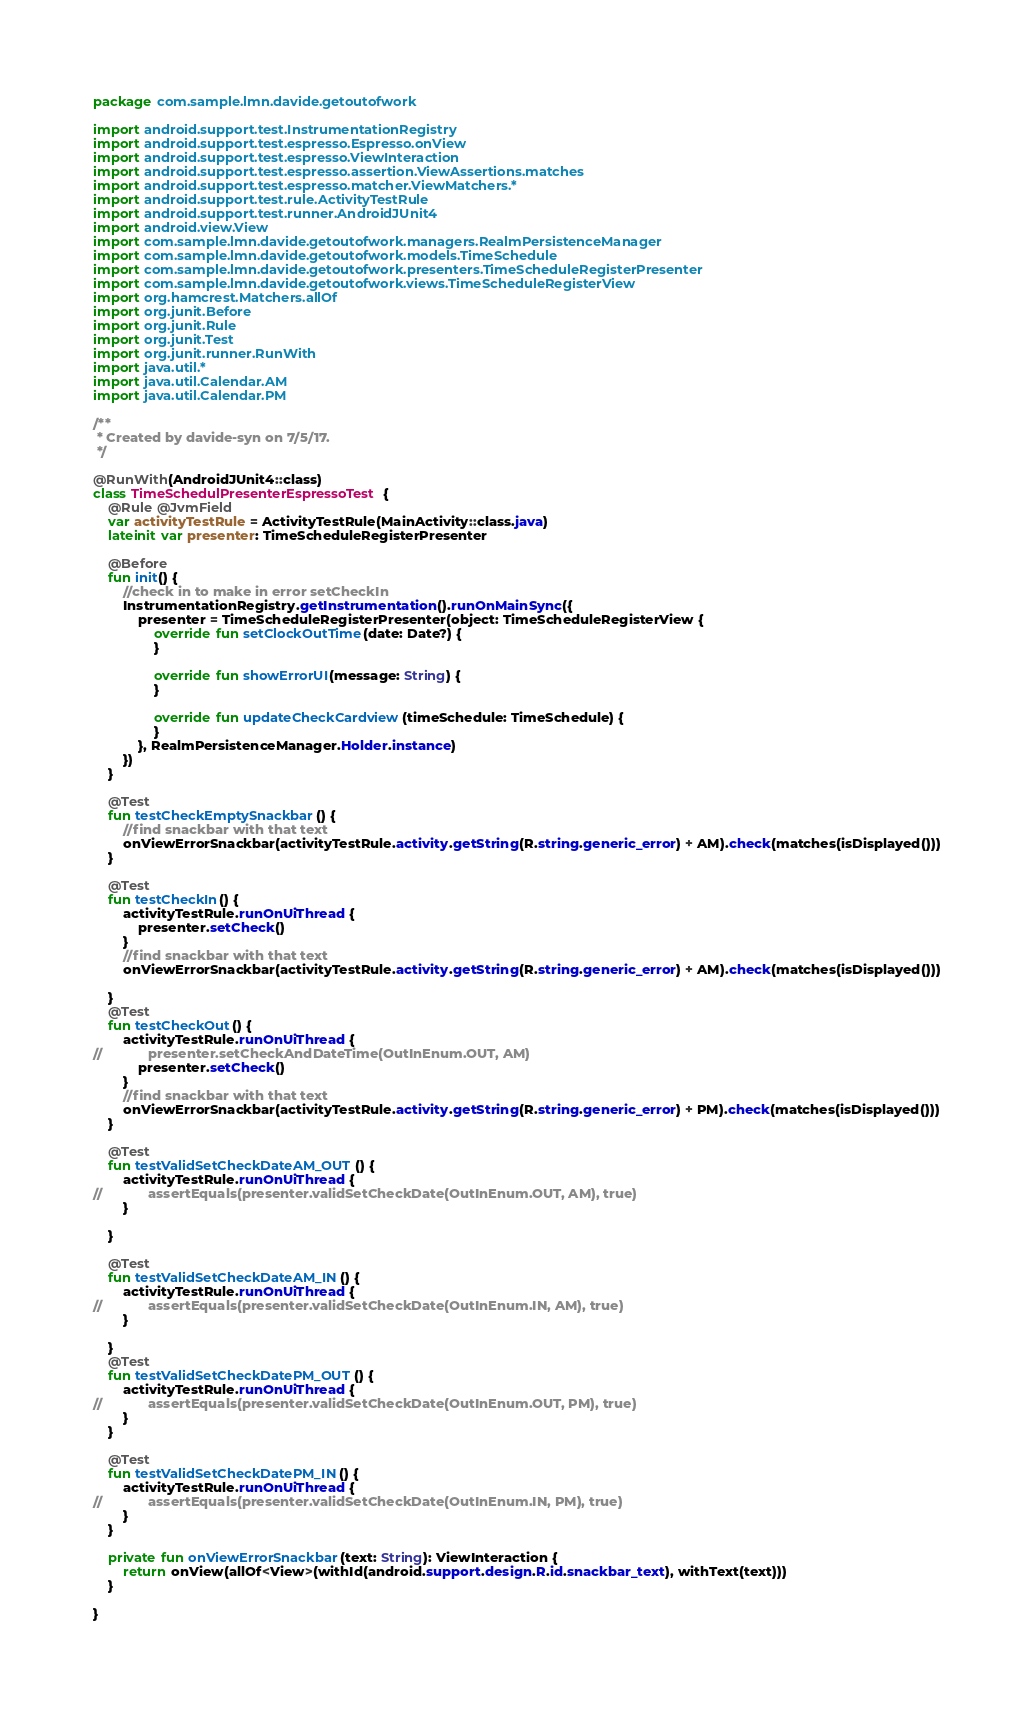Convert code to text. <code><loc_0><loc_0><loc_500><loc_500><_Kotlin_>package com.sample.lmn.davide.getoutofwork

import android.support.test.InstrumentationRegistry
import android.support.test.espresso.Espresso.onView
import android.support.test.espresso.ViewInteraction
import android.support.test.espresso.assertion.ViewAssertions.matches
import android.support.test.espresso.matcher.ViewMatchers.*
import android.support.test.rule.ActivityTestRule
import android.support.test.runner.AndroidJUnit4
import android.view.View
import com.sample.lmn.davide.getoutofwork.managers.RealmPersistenceManager
import com.sample.lmn.davide.getoutofwork.models.TimeSchedule
import com.sample.lmn.davide.getoutofwork.presenters.TimeScheduleRegisterPresenter
import com.sample.lmn.davide.getoutofwork.views.TimeScheduleRegisterView
import org.hamcrest.Matchers.allOf
import org.junit.Before
import org.junit.Rule
import org.junit.Test
import org.junit.runner.RunWith
import java.util.*
import java.util.Calendar.AM
import java.util.Calendar.PM

/**
 * Created by davide-syn on 7/5/17.
 */

@RunWith(AndroidJUnit4::class)
class TimeSchedulPresenterEspressoTest {
    @Rule @JvmField
    var activityTestRule = ActivityTestRule(MainActivity::class.java)
    lateinit var presenter: TimeScheduleRegisterPresenter

    @Before
    fun init() {
        //check in to make in error setCheckIn
        InstrumentationRegistry.getInstrumentation().runOnMainSync({
            presenter = TimeScheduleRegisterPresenter(object: TimeScheduleRegisterView {
                override fun setClockOutTime(date: Date?) {
                }

                override fun showErrorUI(message: String) {
                }

                override fun updateCheckCardview(timeSchedule: TimeSchedule) {
                }
            }, RealmPersistenceManager.Holder.instance)
        })
    }

    @Test
    fun testCheckEmptySnackbar() {
        //find snackbar with that text
        onViewErrorSnackbar(activityTestRule.activity.getString(R.string.generic_error) + AM).check(matches(isDisplayed()))
    }

    @Test
    fun testCheckIn() {
        activityTestRule.runOnUiThread {
            presenter.setCheck()
        }
        //find snackbar with that text
        onViewErrorSnackbar(activityTestRule.activity.getString(R.string.generic_error) + AM).check(matches(isDisplayed()))

    }
    @Test
    fun testCheckOut() {
        activityTestRule.runOnUiThread {
//            presenter.setCheckAndDateTime(OutInEnum.OUT, AM)
            presenter.setCheck()
        }
        //find snackbar with that text
        onViewErrorSnackbar(activityTestRule.activity.getString(R.string.generic_error) + PM).check(matches(isDisplayed()))
    }

    @Test
    fun testValidSetCheckDateAM_OUT() {
        activityTestRule.runOnUiThread {
//            assertEquals(presenter.validSetCheckDate(OutInEnum.OUT, AM), true)
        }

    }

    @Test
    fun testValidSetCheckDateAM_IN() {
        activityTestRule.runOnUiThread {
//            assertEquals(presenter.validSetCheckDate(OutInEnum.IN, AM), true)
        }

    }
    @Test
    fun testValidSetCheckDatePM_OUT() {
        activityTestRule.runOnUiThread {
//            assertEquals(presenter.validSetCheckDate(OutInEnum.OUT, PM), true)
        }
    }

    @Test
    fun testValidSetCheckDatePM_IN() {
        activityTestRule.runOnUiThread {
//            assertEquals(presenter.validSetCheckDate(OutInEnum.IN, PM), true)
        }
    }

    private fun onViewErrorSnackbar(text: String): ViewInteraction {
        return onView(allOf<View>(withId(android.support.design.R.id.snackbar_text), withText(text)))
    }

}
</code> 